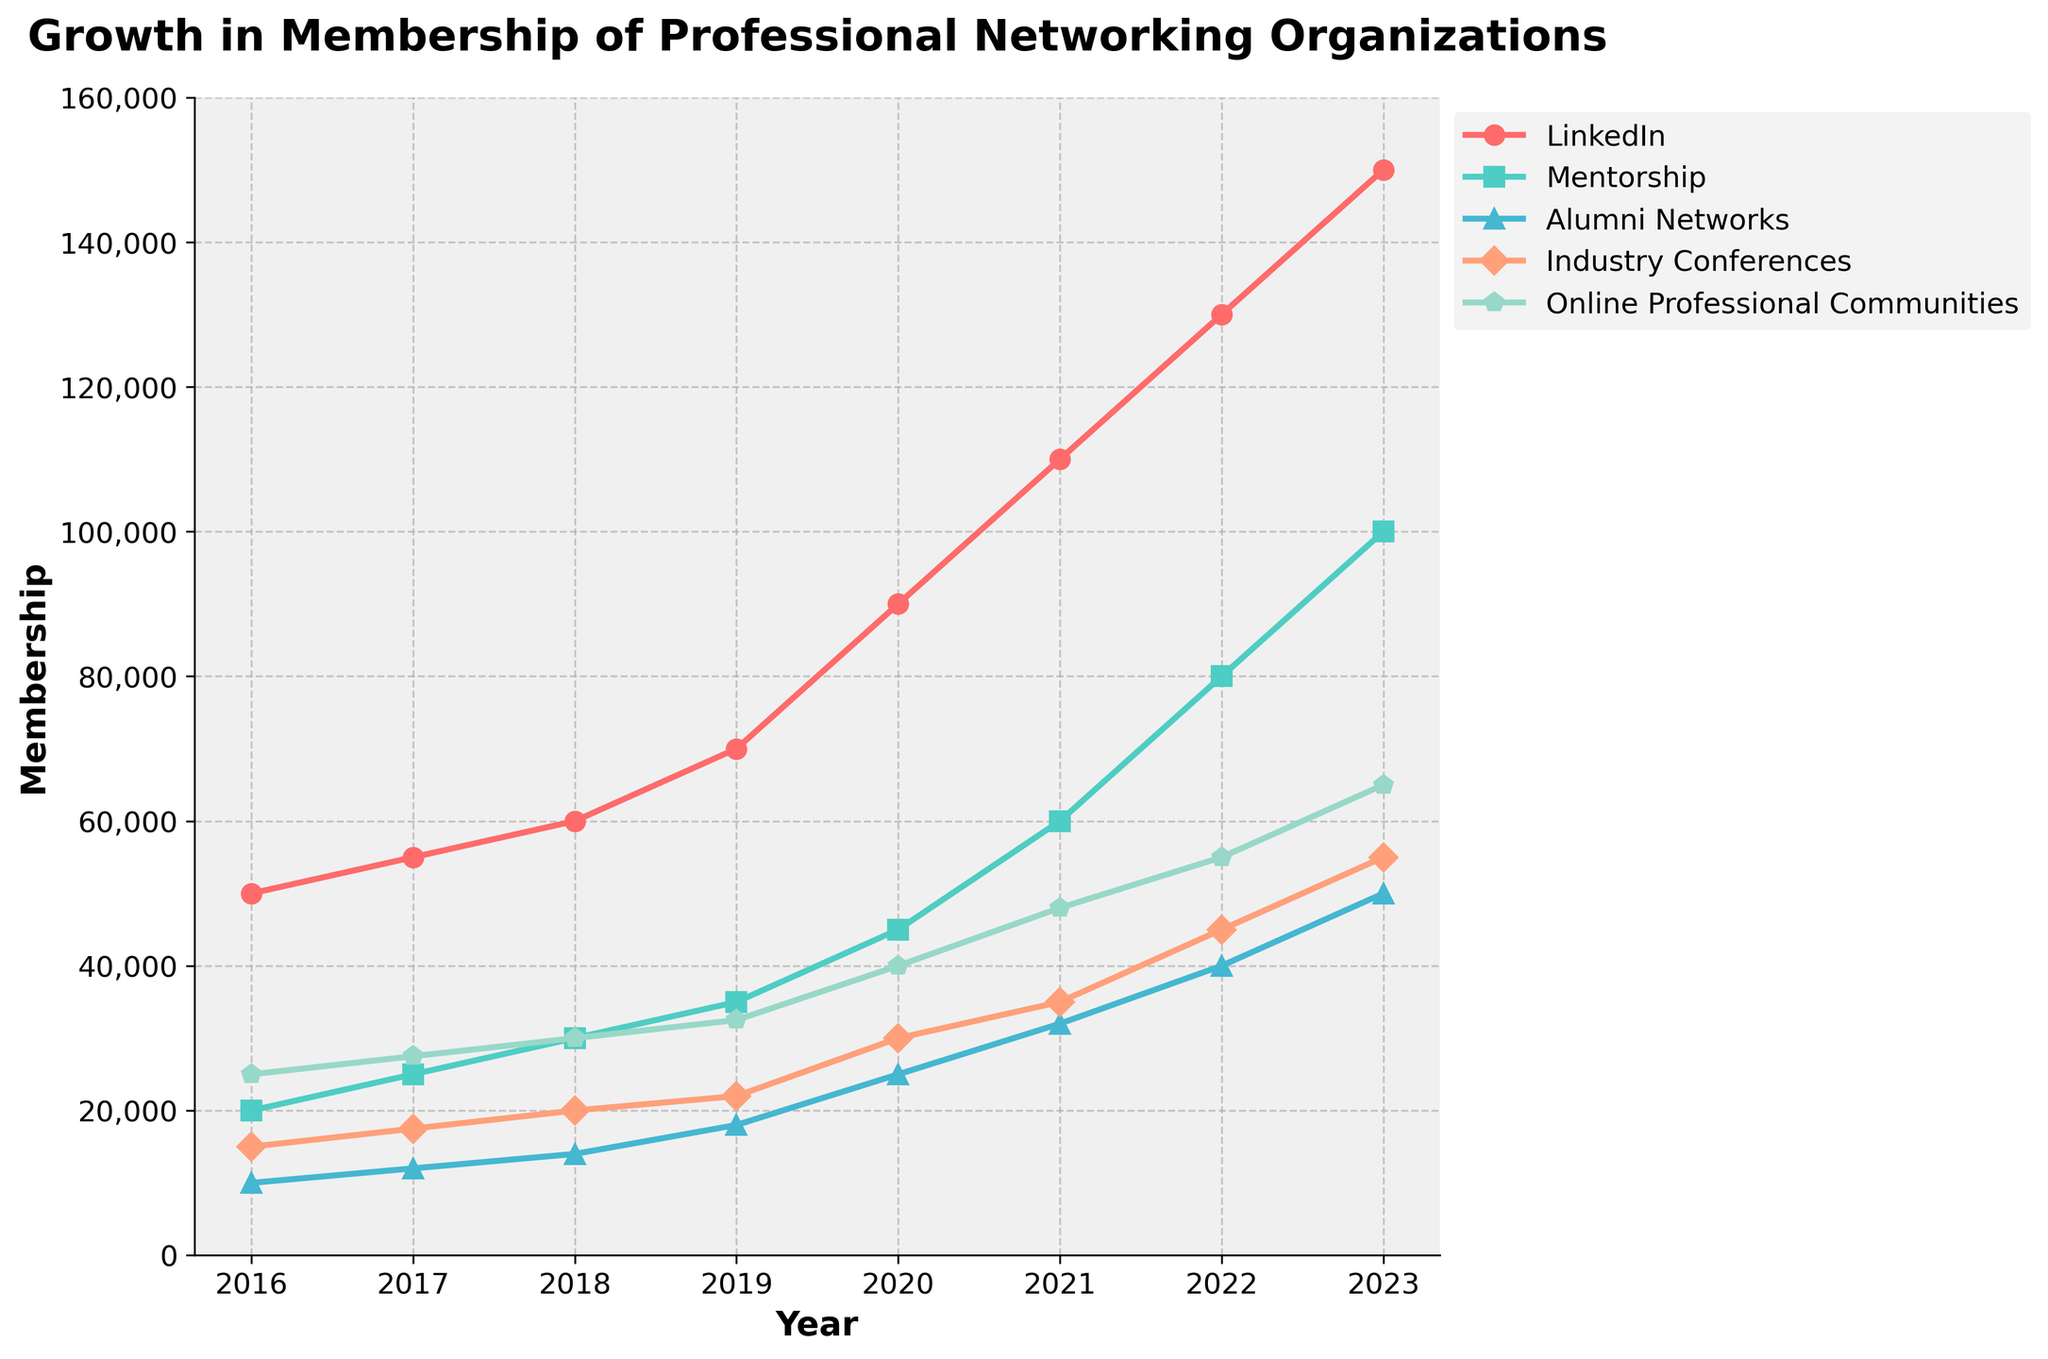What is the title of the figure? The title is shown at the top of the figure and it reads 'Growth in Membership of Professional Networking Organizations'.
Answer: Growth in Membership of Professional Networking Organizations What is the range of years presented in the figure? The x-axis represents the years, ranging from 2016 to 2023.
Answer: 2016 to 2023 Which professional networking organization has the highest membership in 2023? By looking at the endpoints of the lines on the figure for the year 2023, LinkedIn has the highest membership with 150,000.
Answer: LinkedIn How many professional networking organizations are represented in the figure? Each line in the figure represents a different organization. There are five lines, one for each organization: LinkedIn, Mentorship, Alumni Networks, Industry Conferences, and Online Professional Communities.
Answer: Five What is the approximate membership of the Alumni Networks in 2020? To find the value, look at the point corresponding to 2020 on the Alumni Networks line. The membership is about 25,000.
Answer: 25,000 How much did the membership of Mentorship grow between 2016 and 2023? The membership of Mentorship in 2016 was 20,000 and in 2023 it was 100,000. The growth is 100,000 - 20,000 = 80,000.
Answer: 80,000 Which organization saw the largest increase in membership between 2020 and 2021? By examining the steepness of the lines between 2020 and 2021, LinkedIn shows the largest increase, rising from 90,000 to 110,000, an increase of 20,000.
Answer: LinkedIn In which year did Online Professional Communities exceed a membership of 50,000? To find when the line for Online Professional Communities crosses the 50,000 mark on the y-axis, observe that it happens in 2022.
Answer: 2022 What is the combined membership of all organizations in 2019? To find the combined membership, sum the values for 2019: LinkedIn (70,000), Mentorship (35,000), Alumni Networks (18,000), Industry Conferences (22,000), and Online Professional Communities (32,500). The total is 177,500.
Answer: 177,500 Which organization experienced the most stable growth from 2016 to 2023? By examining the lines for consistency in growth without abrupt changes, Online Professional Communities experienced stable growth.
Answer: Online Professional Communities 